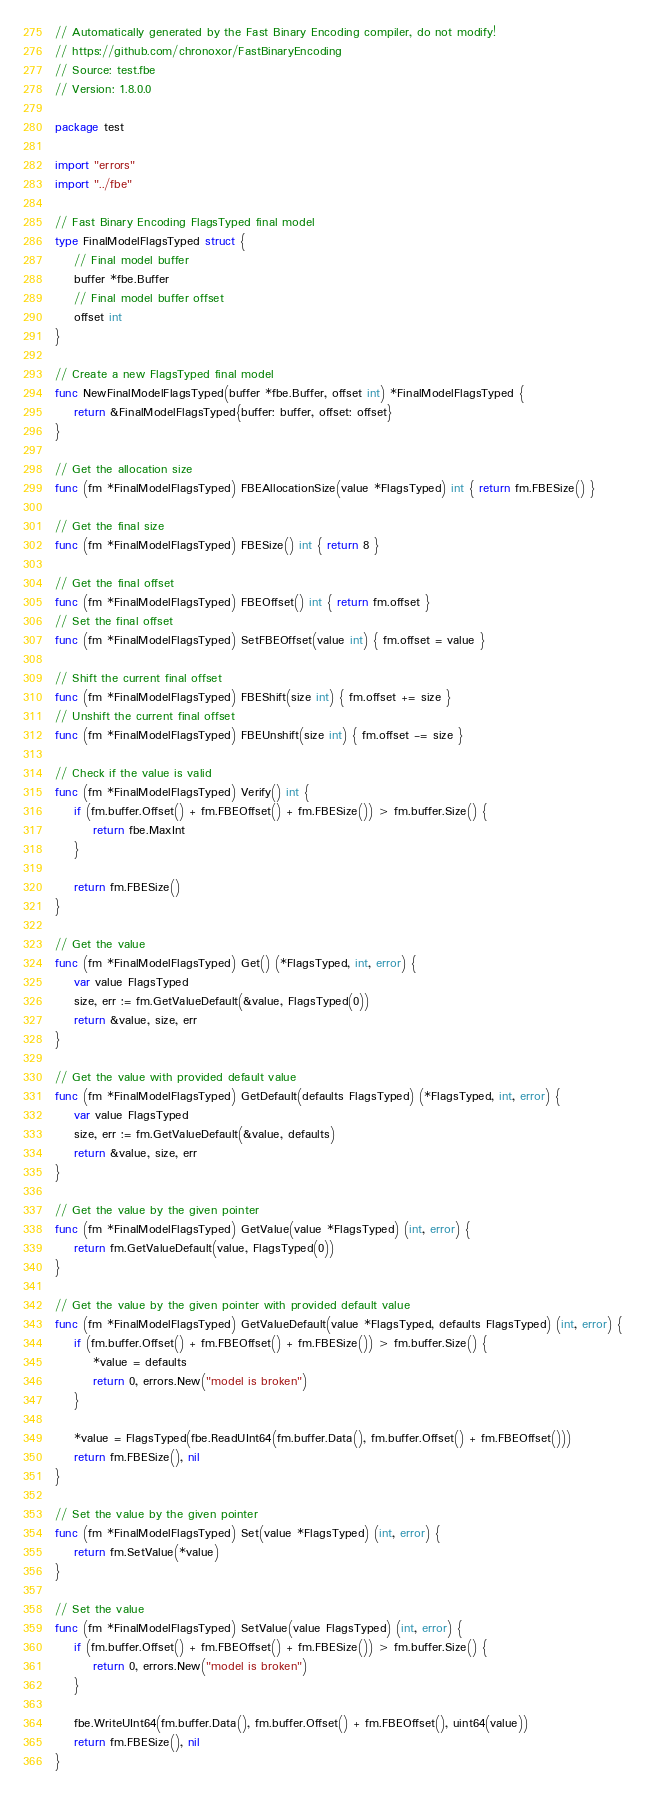Convert code to text. <code><loc_0><loc_0><loc_500><loc_500><_Go_>// Automatically generated by the Fast Binary Encoding compiler, do not modify!
// https://github.com/chronoxor/FastBinaryEncoding
// Source: test.fbe
// Version: 1.8.0.0

package test

import "errors"
import "../fbe"

// Fast Binary Encoding FlagsTyped final model
type FinalModelFlagsTyped struct {
    // Final model buffer
    buffer *fbe.Buffer
    // Final model buffer offset
    offset int
}

// Create a new FlagsTyped final model
func NewFinalModelFlagsTyped(buffer *fbe.Buffer, offset int) *FinalModelFlagsTyped {
    return &FinalModelFlagsTyped{buffer: buffer, offset: offset}
}

// Get the allocation size
func (fm *FinalModelFlagsTyped) FBEAllocationSize(value *FlagsTyped) int { return fm.FBESize() }

// Get the final size
func (fm *FinalModelFlagsTyped) FBESize() int { return 8 }

// Get the final offset
func (fm *FinalModelFlagsTyped) FBEOffset() int { return fm.offset }
// Set the final offset
func (fm *FinalModelFlagsTyped) SetFBEOffset(value int) { fm.offset = value }

// Shift the current final offset
func (fm *FinalModelFlagsTyped) FBEShift(size int) { fm.offset += size }
// Unshift the current final offset
func (fm *FinalModelFlagsTyped) FBEUnshift(size int) { fm.offset -= size }

// Check if the value is valid
func (fm *FinalModelFlagsTyped) Verify() int {
    if (fm.buffer.Offset() + fm.FBEOffset() + fm.FBESize()) > fm.buffer.Size() {
        return fbe.MaxInt
    }

    return fm.FBESize()
}

// Get the value
func (fm *FinalModelFlagsTyped) Get() (*FlagsTyped, int, error) {
    var value FlagsTyped
    size, err := fm.GetValueDefault(&value, FlagsTyped(0))
    return &value, size, err
}

// Get the value with provided default value
func (fm *FinalModelFlagsTyped) GetDefault(defaults FlagsTyped) (*FlagsTyped, int, error) {
    var value FlagsTyped
    size, err := fm.GetValueDefault(&value, defaults)
    return &value, size, err
}

// Get the value by the given pointer
func (fm *FinalModelFlagsTyped) GetValue(value *FlagsTyped) (int, error) {
    return fm.GetValueDefault(value, FlagsTyped(0))
}

// Get the value by the given pointer with provided default value
func (fm *FinalModelFlagsTyped) GetValueDefault(value *FlagsTyped, defaults FlagsTyped) (int, error) {
    if (fm.buffer.Offset() + fm.FBEOffset() + fm.FBESize()) > fm.buffer.Size() {
        *value = defaults
        return 0, errors.New("model is broken")
    }

    *value = FlagsTyped(fbe.ReadUInt64(fm.buffer.Data(), fm.buffer.Offset() + fm.FBEOffset()))
    return fm.FBESize(), nil
}

// Set the value by the given pointer
func (fm *FinalModelFlagsTyped) Set(value *FlagsTyped) (int, error) {
    return fm.SetValue(*value)
}

// Set the value
func (fm *FinalModelFlagsTyped) SetValue(value FlagsTyped) (int, error) {
    if (fm.buffer.Offset() + fm.FBEOffset() + fm.FBESize()) > fm.buffer.Size() {
        return 0, errors.New("model is broken")
    }

    fbe.WriteUInt64(fm.buffer.Data(), fm.buffer.Offset() + fm.FBEOffset(), uint64(value))
    return fm.FBESize(), nil
}
</code> 